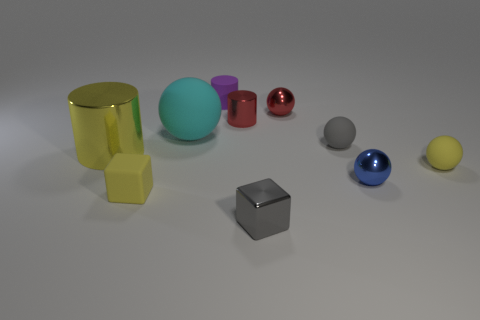Subtract all gray spheres. How many spheres are left? 4 Subtract all tiny yellow spheres. How many spheres are left? 4 Subtract all green spheres. Subtract all gray cylinders. How many spheres are left? 5 Subtract all cubes. How many objects are left? 8 Add 6 red metal balls. How many red metal balls exist? 7 Subtract 0 cyan cylinders. How many objects are left? 10 Subtract all tiny yellow things. Subtract all gray rubber objects. How many objects are left? 7 Add 3 small blue metallic balls. How many small blue metallic balls are left? 4 